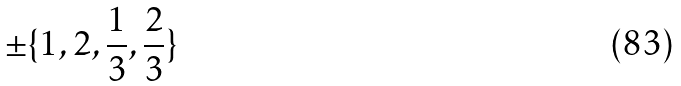Convert formula to latex. <formula><loc_0><loc_0><loc_500><loc_500>\pm \{ 1 , 2 , \frac { 1 } { 3 } , \frac { 2 } { 3 } \}</formula> 